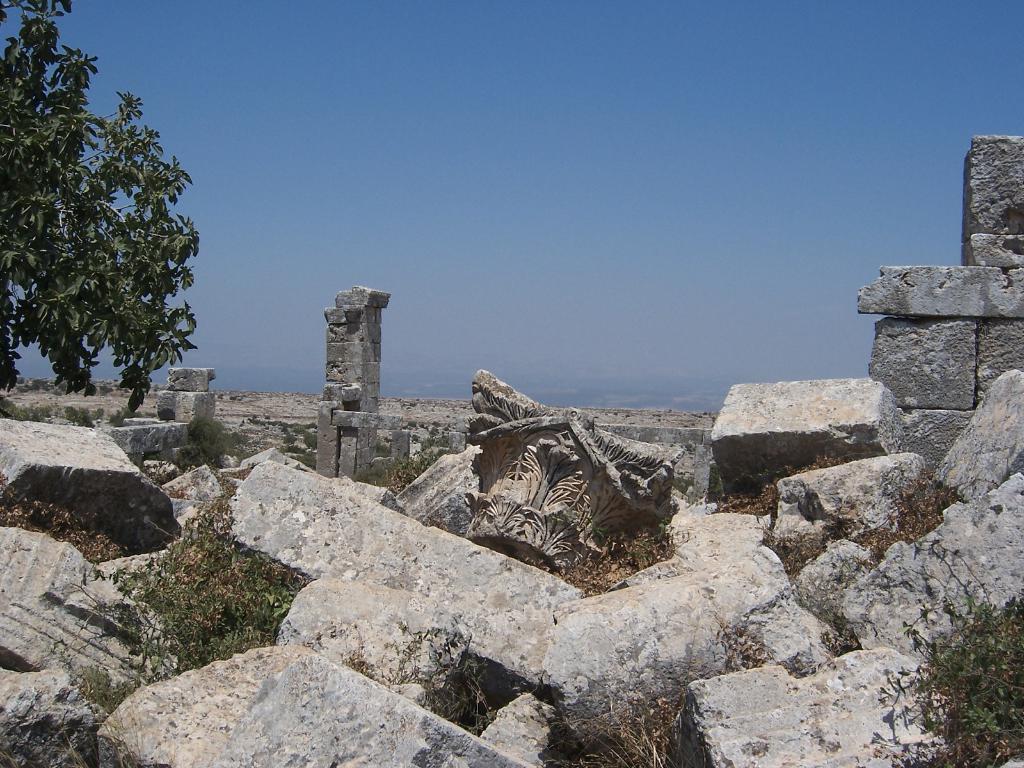In one or two sentences, can you explain what this image depicts? In this image in front there are rocks. In the background of the image there are trees and sky. 